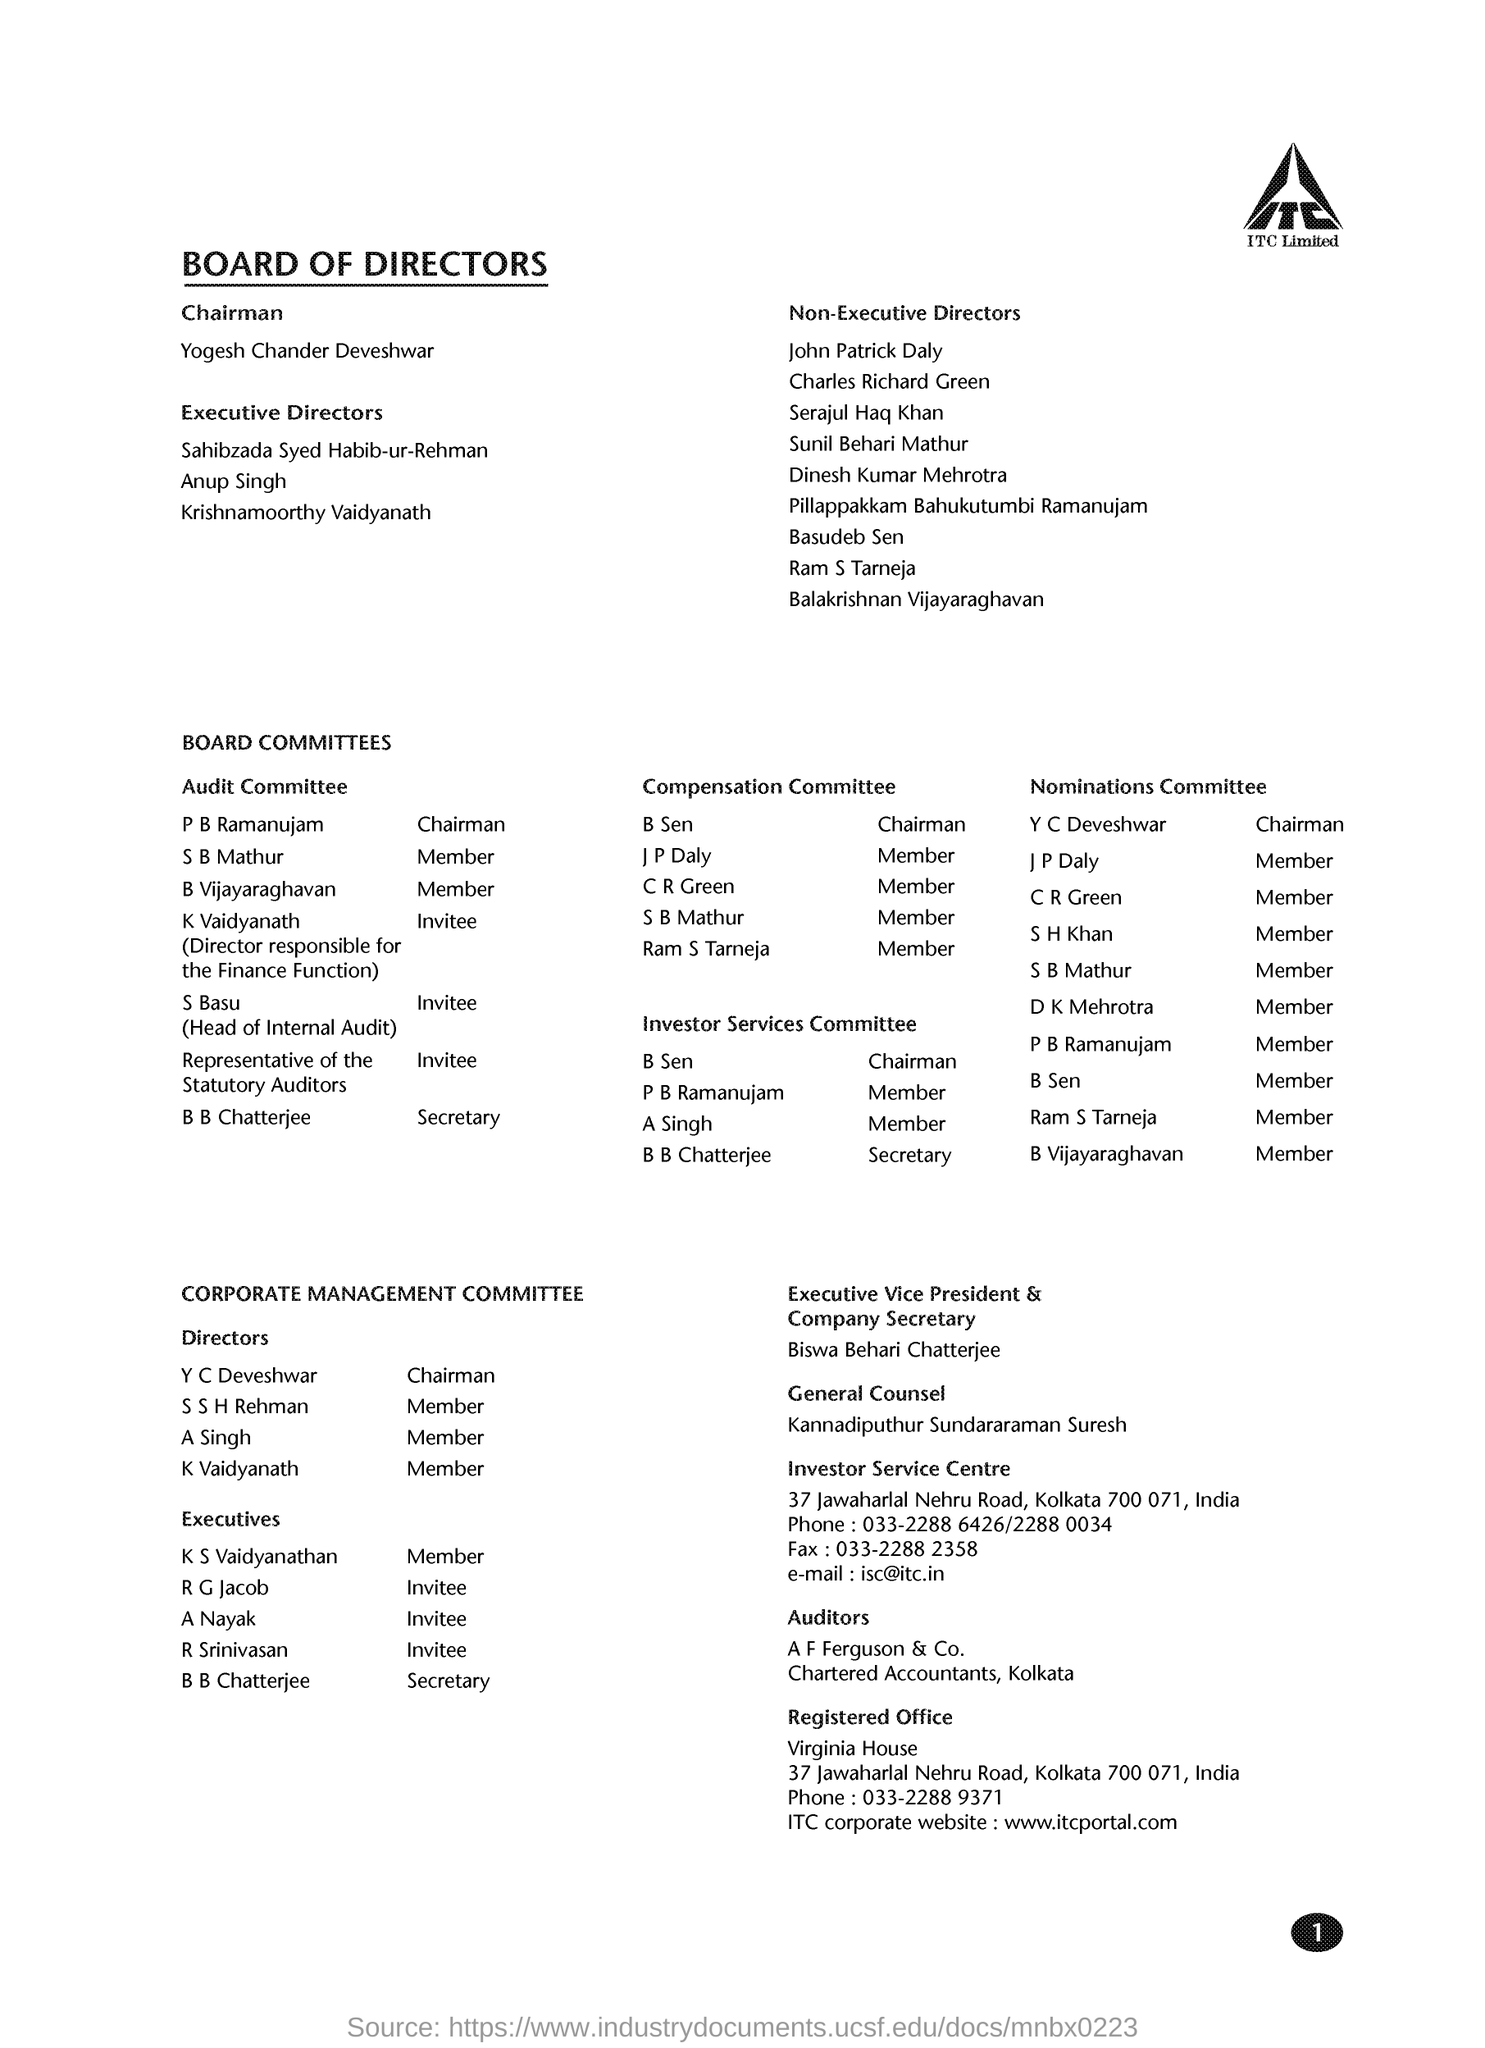Highlight a few significant elements in this photo. The registered office is located in Kolkata. The executive vice president of the company is Biswa Behari Chatterjee. The document mentions ITC Limited as a company. 